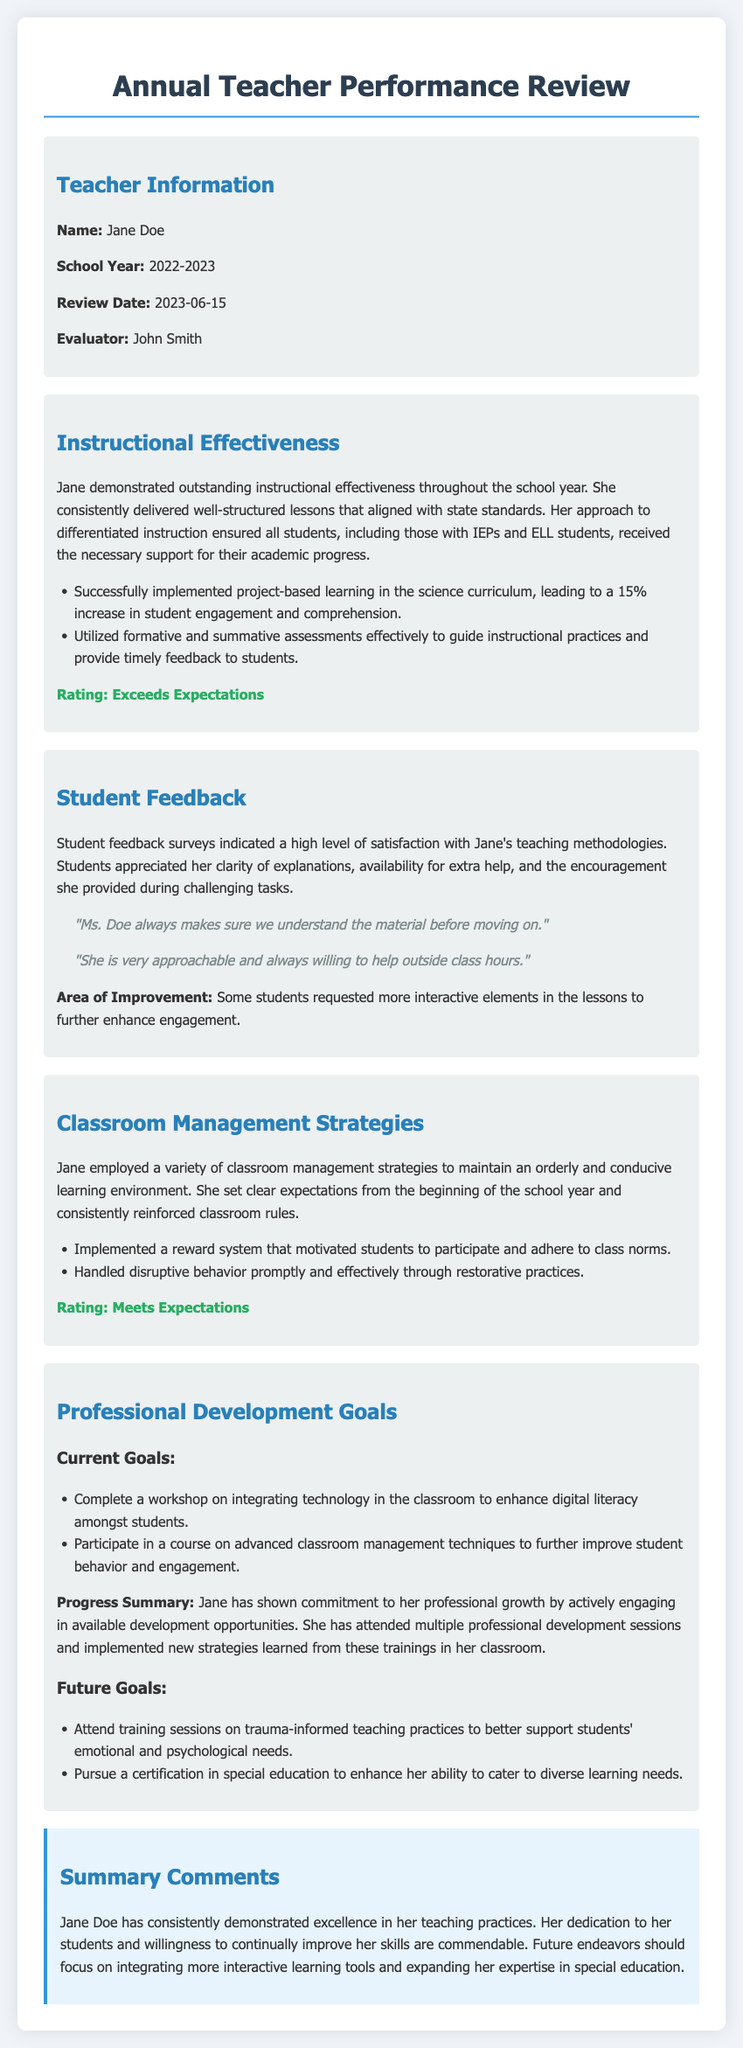What is the name of the teacher? The teacher's name is specified in the document under the Teacher Information section.
Answer: Jane Doe What is the review date? The review date is indicated in the Teacher Information section of the document.
Answer: 2023-06-15 What rating did Jane receive for Instructional Effectiveness? The rating for Instructional Effectiveness can be found in the corresponding section of the document.
Answer: Exceeds Expectations What is one area of improvement noted in student feedback? The area of improvement is mentioned in the Student Feedback section regarding elements to enhance engagement.
Answer: More interactive elements What strategy did Jane implement to motivate students? This information is provided in the Classroom Management Strategies section about how Jane encouraged student participation.
Answer: Reward system What is one current professional development goal for Jane? The document lists specific goals under the Professional Development Goals section; one can be retrieved directly from that list.
Answer: Complete a workshop on integrating technology How many percent increase in student engagement was noted due to project-based learning? The percentage increase is given in the instructional effectiveness details, making it a quantitative retrieval question.
Answer: 15% What does Jane plan to pursue to enhance her ability with diverse learning needs? This is mentioned in the Future Goals section of the Professional Development Goals.
Answer: Certification in special education What is the overall summary comment about Jane? The summary comment can be found in the Summary Comments section and reflects her performance.
Answer: Consistently demonstrated excellence 